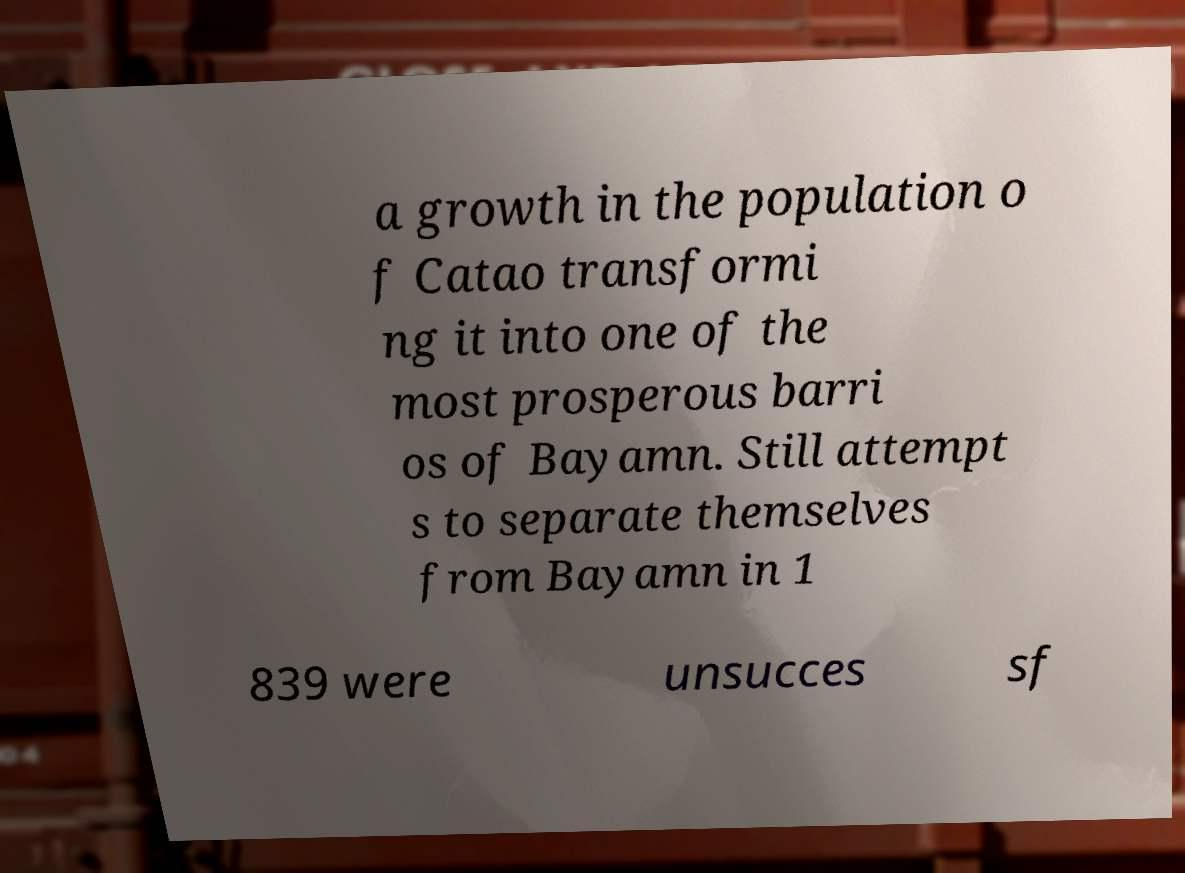Could you extract and type out the text from this image? a growth in the population o f Catao transformi ng it into one of the most prosperous barri os of Bayamn. Still attempt s to separate themselves from Bayamn in 1 839 were unsucces sf 